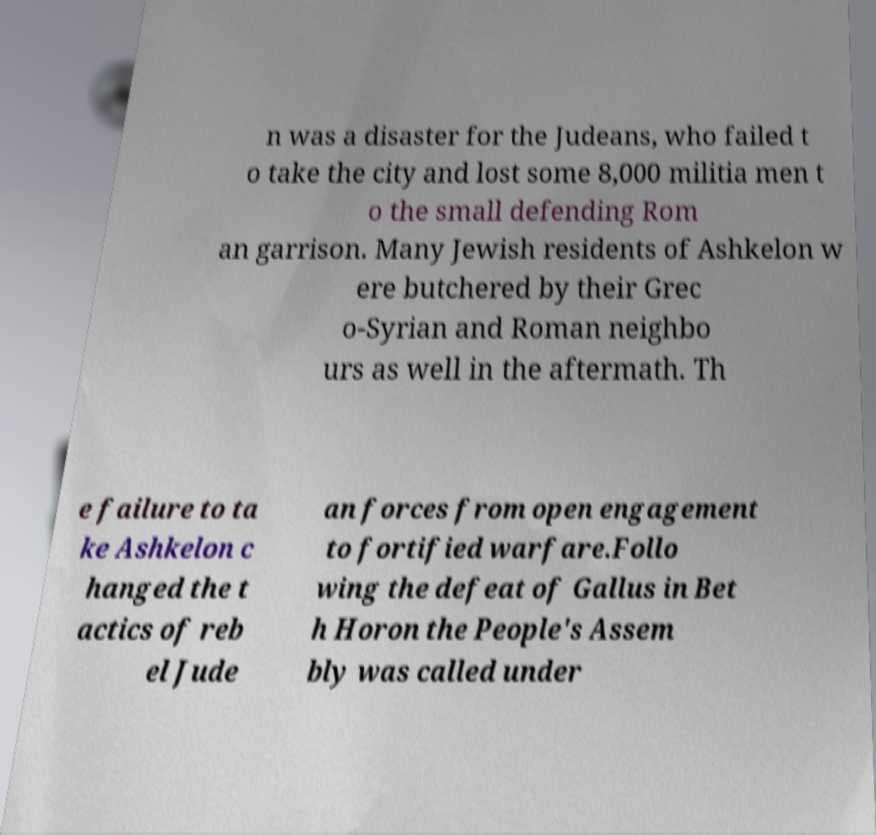Please identify and transcribe the text found in this image. n was a disaster for the Judeans, who failed t o take the city and lost some 8,000 militia men t o the small defending Rom an garrison. Many Jewish residents of Ashkelon w ere butchered by their Grec o-Syrian and Roman neighbo urs as well in the aftermath. Th e failure to ta ke Ashkelon c hanged the t actics of reb el Jude an forces from open engagement to fortified warfare.Follo wing the defeat of Gallus in Bet h Horon the People's Assem bly was called under 